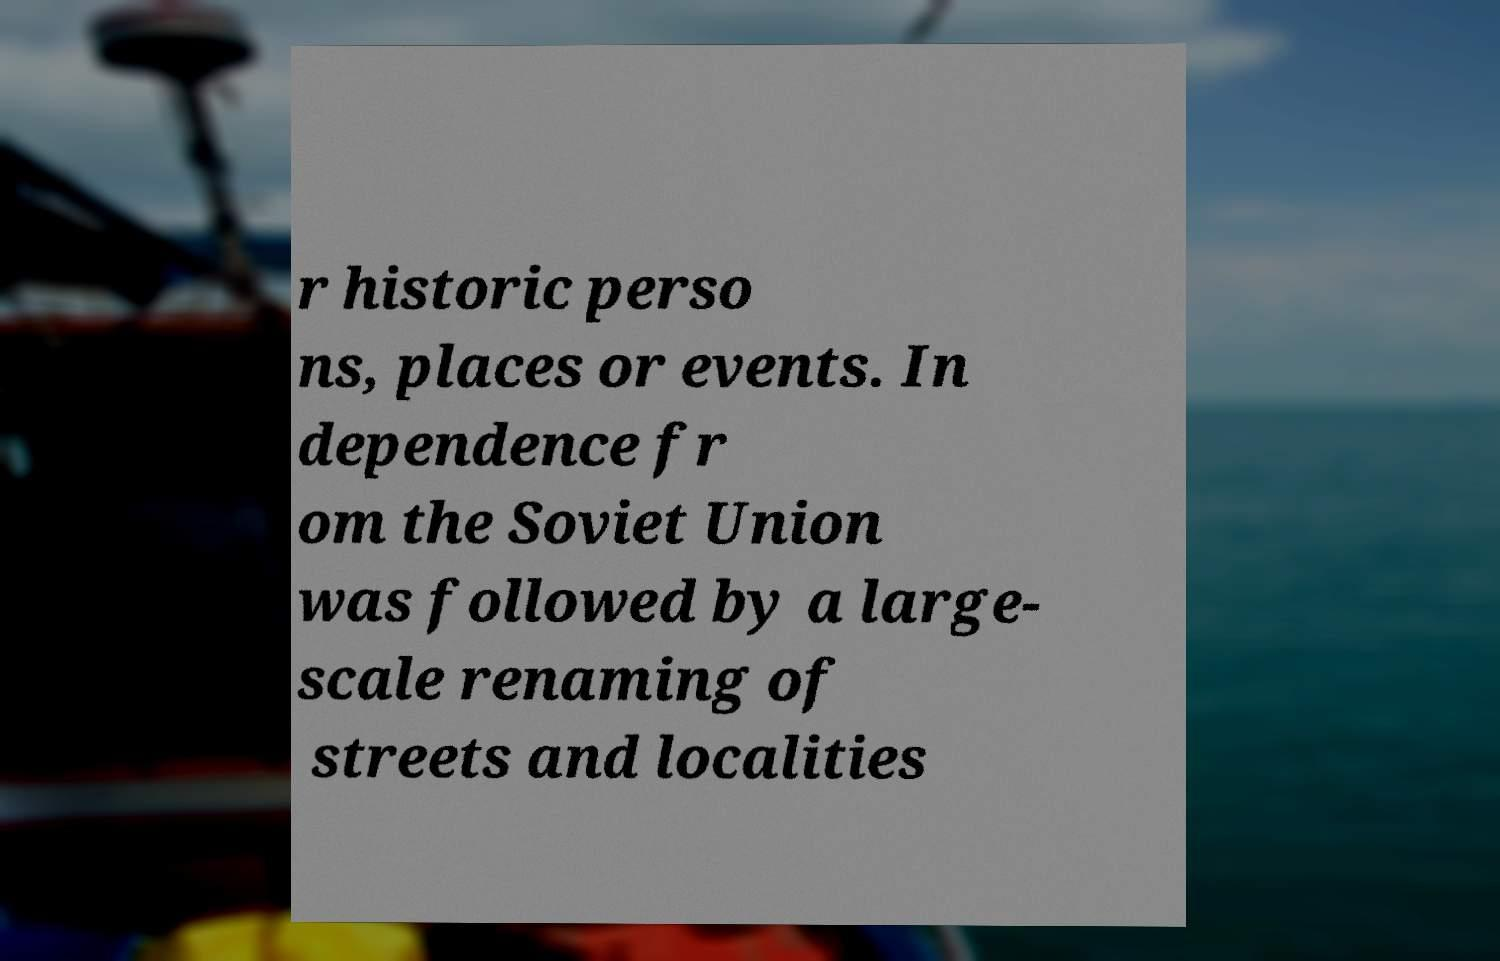Please read and relay the text visible in this image. What does it say? r historic perso ns, places or events. In dependence fr om the Soviet Union was followed by a large- scale renaming of streets and localities 